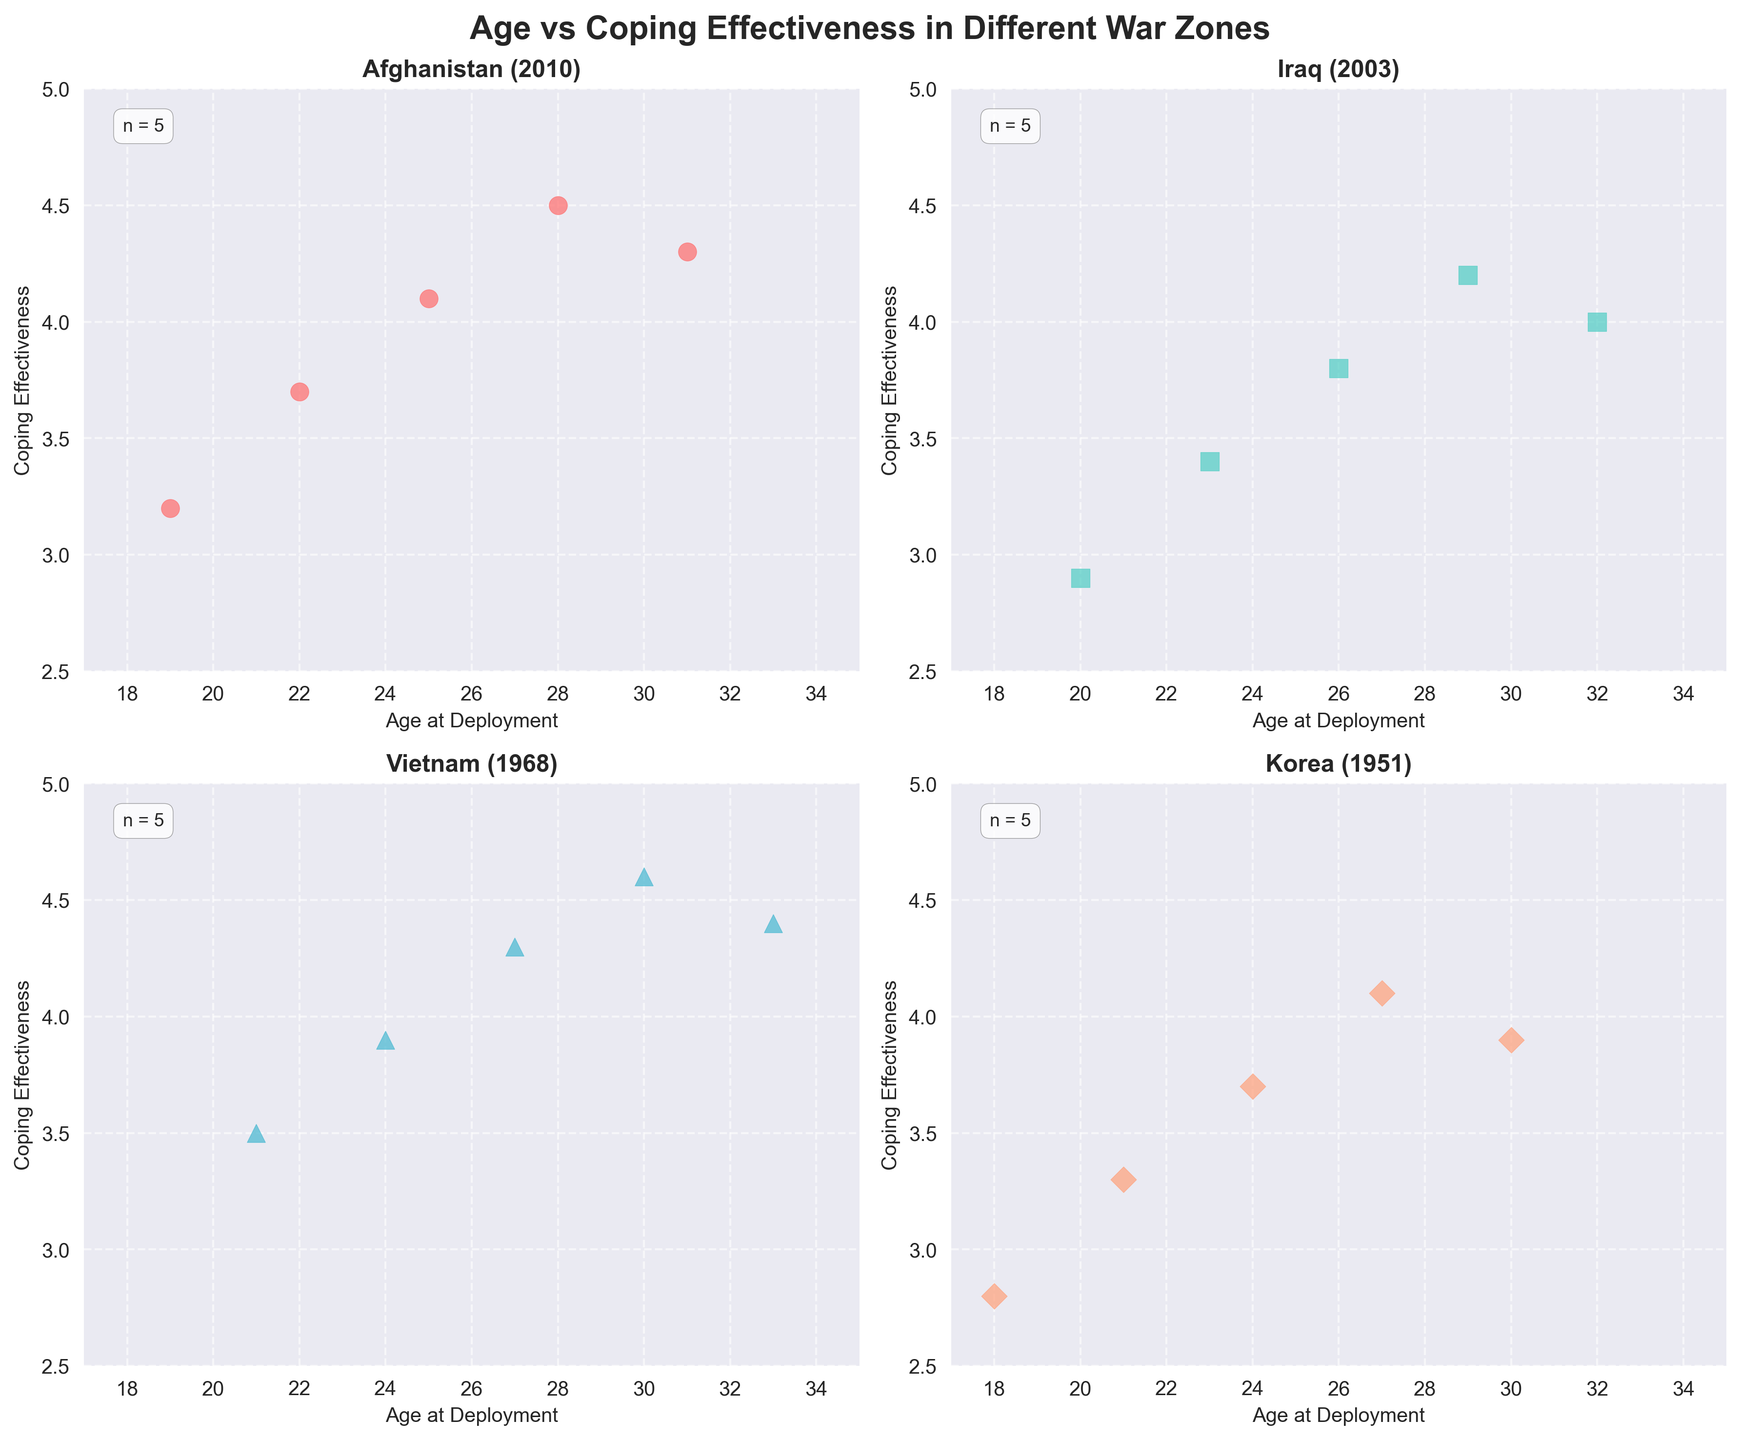What is the title of the plot? The title is located at the top center of the plot. It reads "Age vs Coping Effectiveness in Different War Zones".
Answer: Age vs Coping Effectiveness in Different War Zones How many data points are there in the Afghanistan subplot? Count the number of data points in the Afghanistan scatter plot, including all ages and coping effectiveness points.
Answer: 5 Which war zone subplot has the highest coping effectiveness value? Look for the maximum value on the y-axis labeled "Coping Effectiveness" across all subplots. The highest value (4.6) is in the Vietnam subplot.
Answer: Vietnam What is the average coping effectiveness for soldiers deployed in Iraq? Identify the Iraq subplot and note the coping effectiveness values (2.9, 3.4, 3.8, 4.2, 4.0). Calculate the average by summing these values and dividing by the number of points. (2.9 + 3.4 + 3.8 + 4.2 + 4.0) / 5 = 3.66
Answer: 3.66 Which war zone subplot has the lowest average coping effectiveness? Calculate the average coping effectiveness for each war zone and compare them. The war zones are Korea (average: 3.56), Iraq (average: 3.66), Afghanistan (average: 3.96), and Vietnam (average: 4.14). The lowest average is in Korea.
Answer: Korea What is the difference in the highest coping effectiveness between Korea and Afghanistan subplots? Find the maximum coping effectiveness for Korea (4.1) and Afghanistan (4.5). Subtract the values: 4.5 - 4.1.
Answer: 0.4 In which war zone does coping effectiveness seem to increase the most rapidly with age? Examine the trend lines for each subplot to see how steeply the coping effectiveness values increase with age. The steepest increase appears to be in Afghanistan.
Answer: Afghanistan Which subplot has the widest age range at deployment? Compare the age ranges by identifying the minimum and maximum ages in each subplot. Afghanistan: 19-31, Iraq: 20-32, Vietnam: 21-33, Korea: 18-30. The widest range is in Iraq and Vietnam (12 years).
Answer: Iraq and Vietnam For which war zone does coping effectiveness not show a clear increasing trend with age? Look for a war zone where the coping effectiveness values do not consistently increase with age. Iraq has some variations where the values do not always increase.
Answer: Iraq 